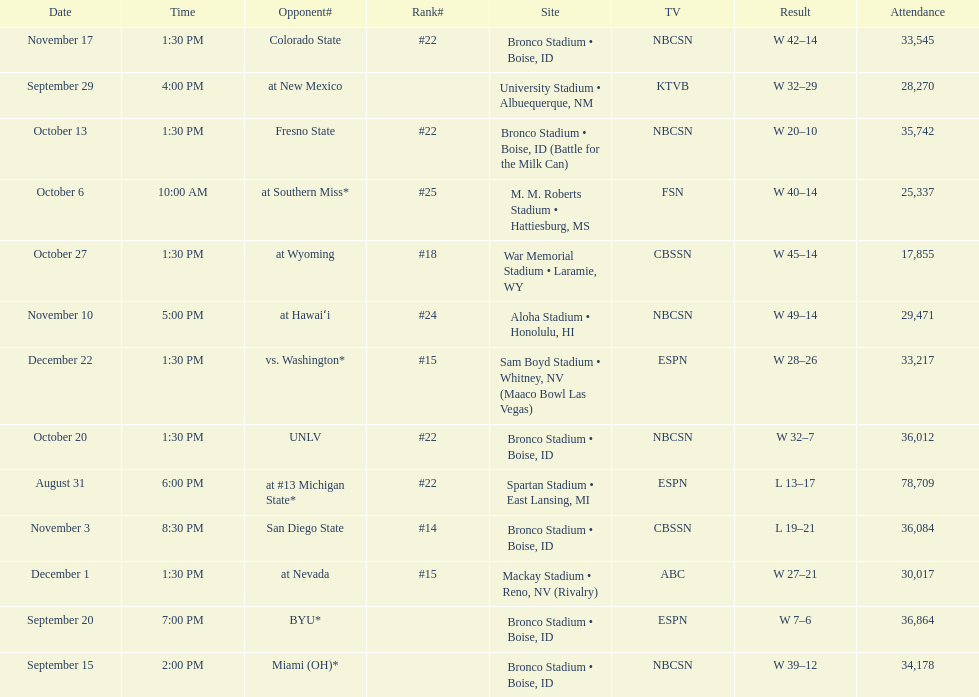Which team has the highest rank among those listed? San Diego State. 